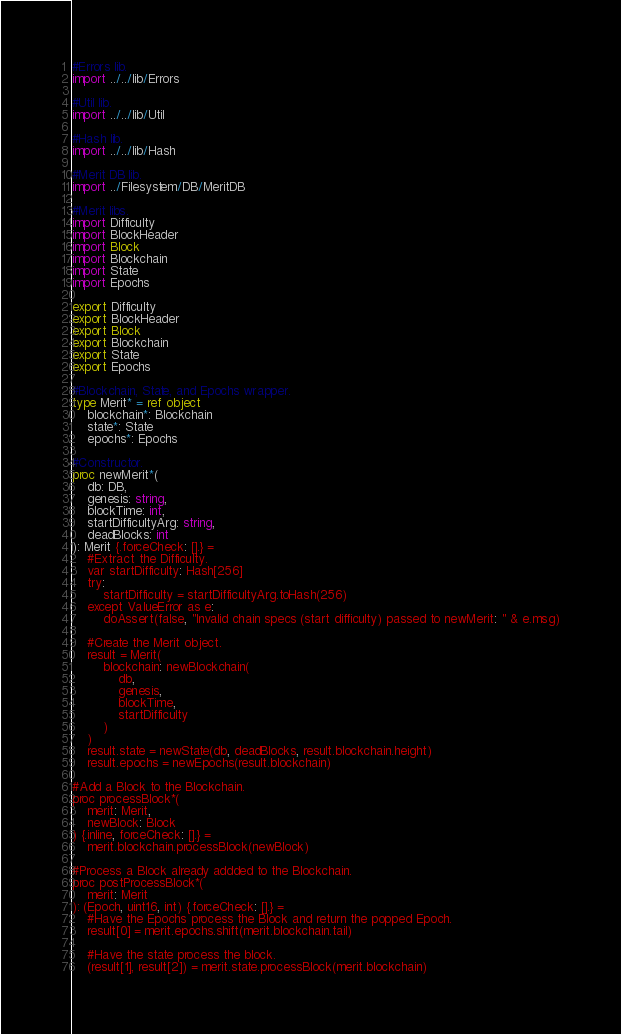<code> <loc_0><loc_0><loc_500><loc_500><_Nim_>#Errors lib.
import ../../lib/Errors

#Util lib.
import ../../lib/Util

#Hash lib.
import ../../lib/Hash

#Merit DB lib.
import ../Filesystem/DB/MeritDB

#Merit libs.
import Difficulty
import BlockHeader
import Block
import Blockchain
import State
import Epochs

export Difficulty
export BlockHeader
export Block
export Blockchain
export State
export Epochs

#Blockchain, State, and Epochs wrapper.
type Merit* = ref object
    blockchain*: Blockchain
    state*: State
    epochs*: Epochs

#Constructor.
proc newMerit*(
    db: DB,
    genesis: string,
    blockTime: int,
    startDifficultyArg: string,
    deadBlocks: int
): Merit {.forceCheck: [].} =
    #Extract the Difficulty.
    var startDifficulty: Hash[256]
    try:
        startDifficulty = startDifficultyArg.toHash(256)
    except ValueError as e:
        doAssert(false, "Invalid chain specs (start difficulty) passed to newMerit: " & e.msg)

    #Create the Merit object.
    result = Merit(
        blockchain: newBlockchain(
            db,
            genesis,
            blockTime,
            startDifficulty
        )
    )
    result.state = newState(db, deadBlocks, result.blockchain.height)
    result.epochs = newEpochs(result.blockchain)

#Add a Block to the Blockchain.
proc processBlock*(
    merit: Merit,
    newBlock: Block
) {.inline, forceCheck: [].} =
    merit.blockchain.processBlock(newBlock)

#Process a Block already addded to the Blockchain.
proc postProcessBlock*(
    merit: Merit
): (Epoch, uint16, int) {.forceCheck: [].} =
    #Have the Epochs process the Block and return the popped Epoch.
    result[0] = merit.epochs.shift(merit.blockchain.tail)

    #Have the state process the block.
    (result[1], result[2]) = merit.state.processBlock(merit.blockchain)
</code> 